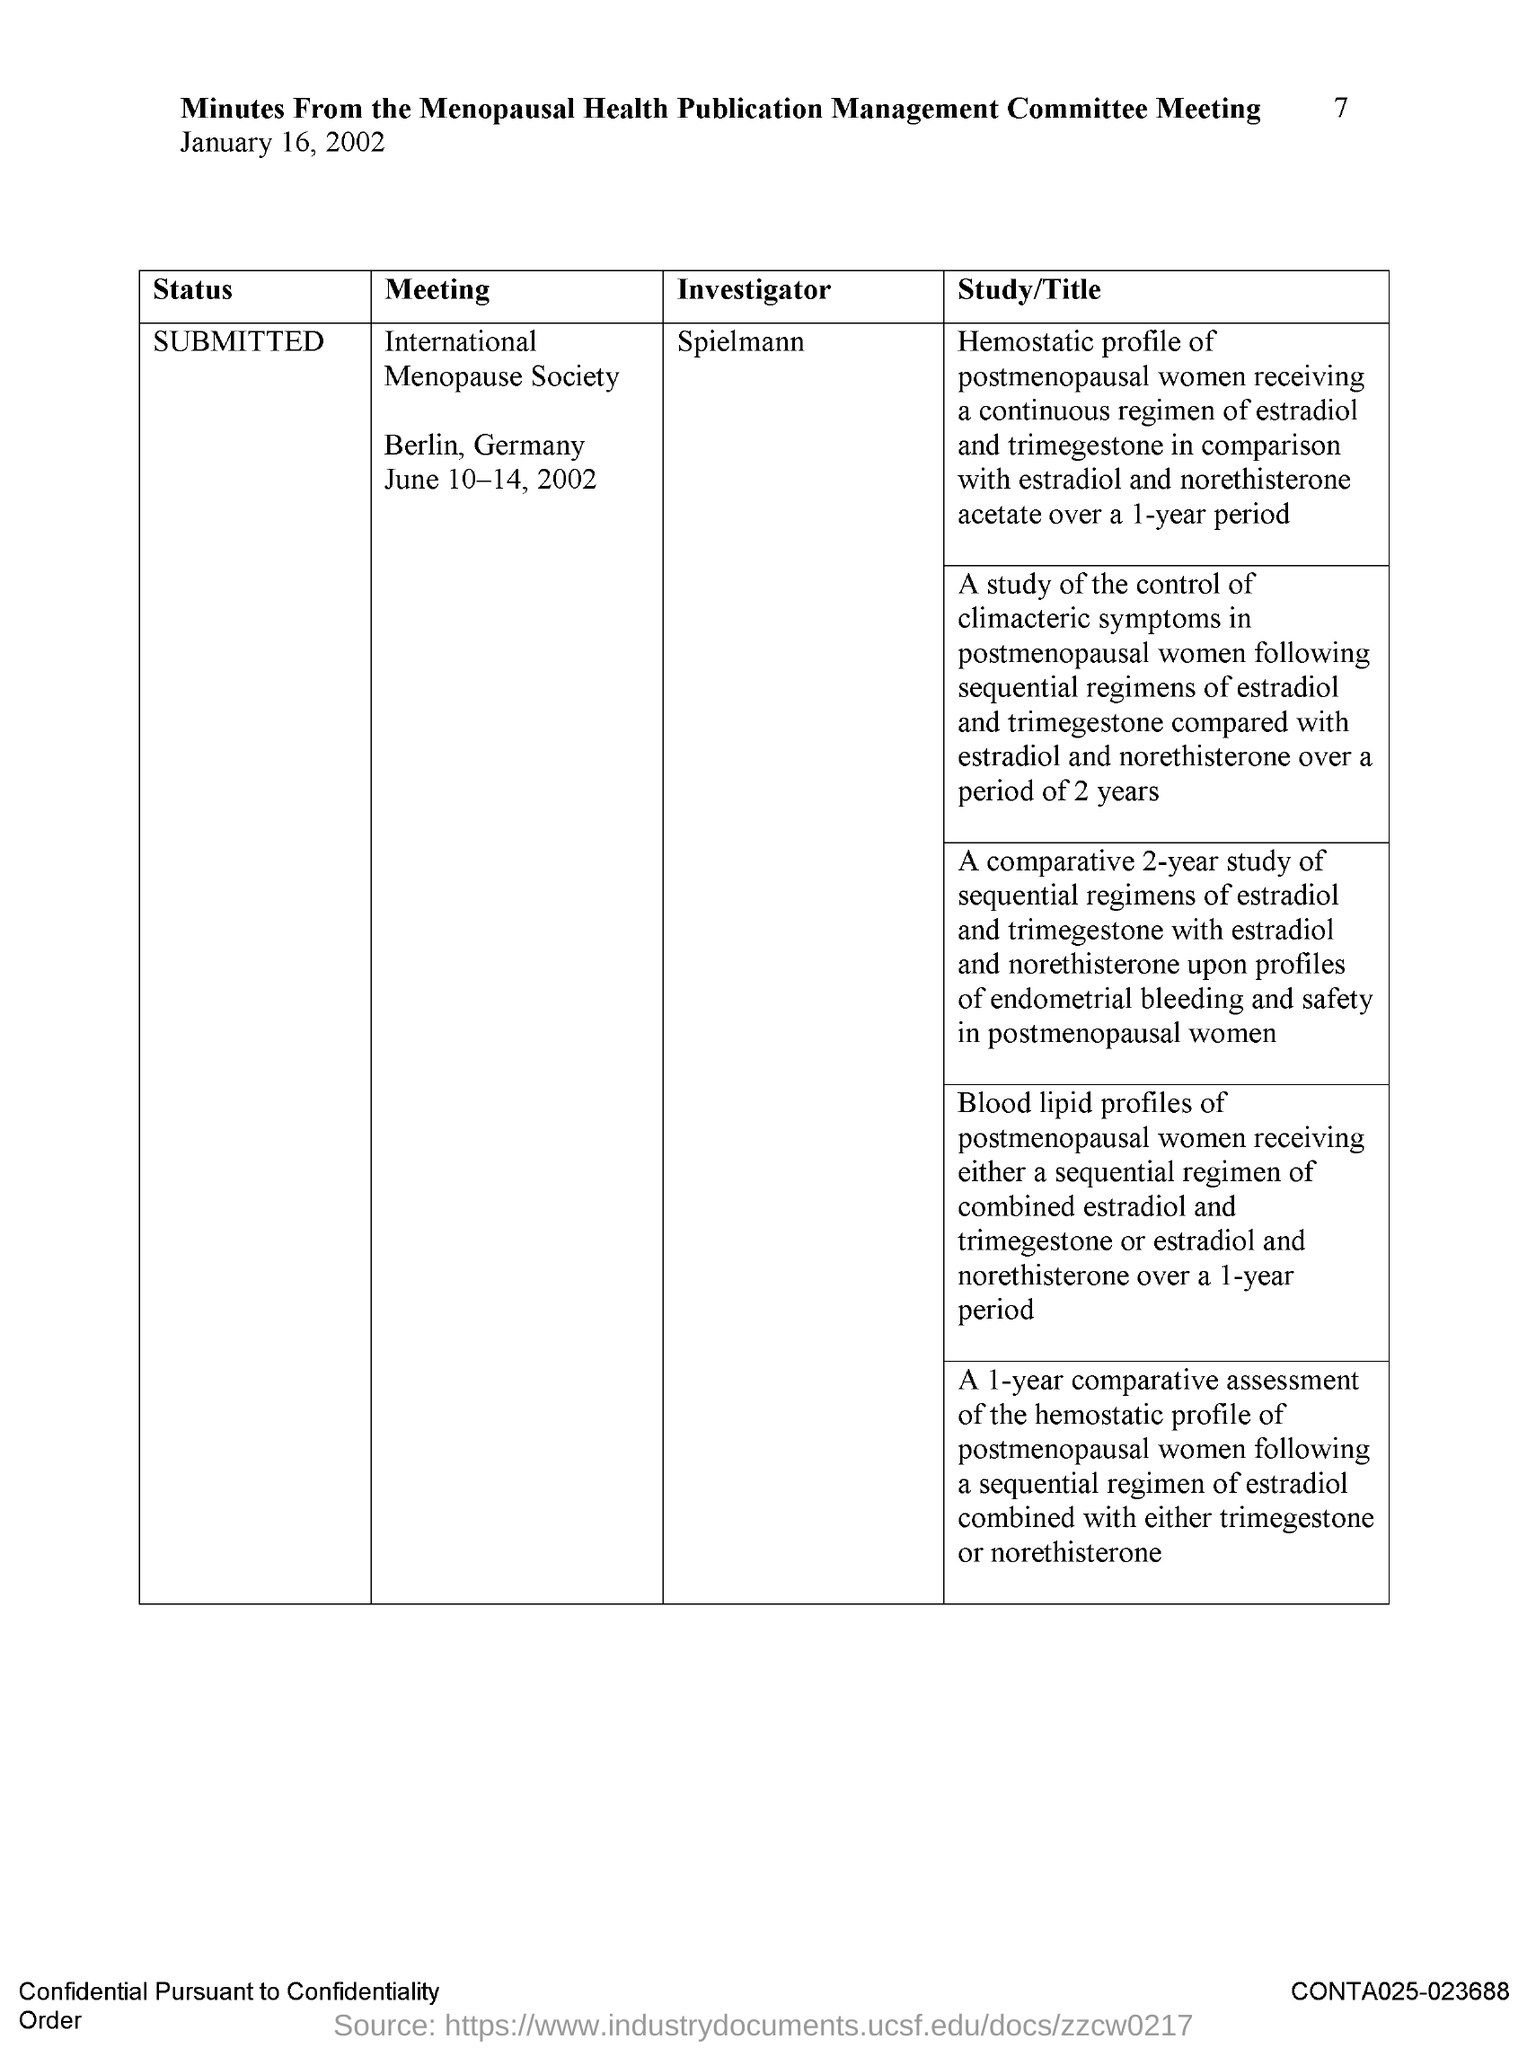When is the document dated?
Provide a short and direct response. January 16, 2002. Who is the investigator?
Your response must be concise. Spielmann. What is the meeting about?
Offer a very short reply. International Menopause society. When is the meeting going to be held?
Ensure brevity in your answer.  June 10-14, 2002. Where is the meeting?
Your response must be concise. Berlin. 